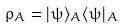Convert formula to latex. <formula><loc_0><loc_0><loc_500><loc_500>\rho _ { A } = | \psi \rangle _ { A } \langle \psi | _ { A }</formula> 